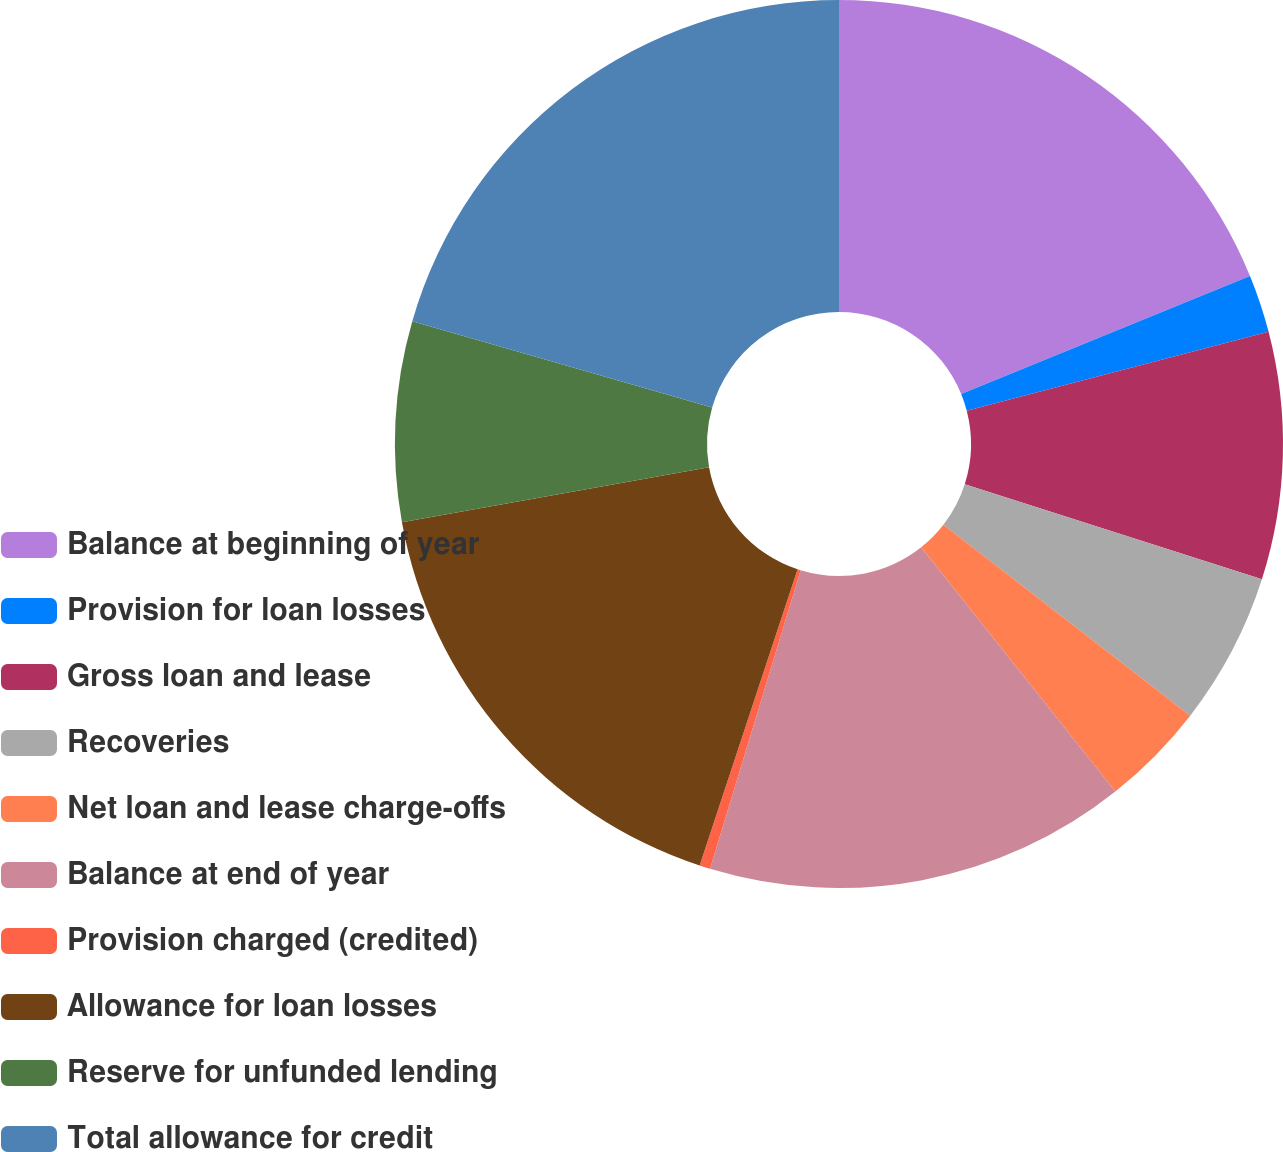Convert chart to OTSL. <chart><loc_0><loc_0><loc_500><loc_500><pie_chart><fcel>Balance at beginning of year<fcel>Provision for loan losses<fcel>Gross loan and lease<fcel>Recoveries<fcel>Net loan and lease charge-offs<fcel>Balance at end of year<fcel>Provision charged (credited)<fcel>Allowance for loan losses<fcel>Reserve for unfunded lending<fcel>Total allowance for credit<nl><fcel>18.82%<fcel>2.11%<fcel>8.99%<fcel>5.55%<fcel>3.83%<fcel>15.38%<fcel>0.39%<fcel>17.1%<fcel>7.27%<fcel>20.54%<nl></chart> 